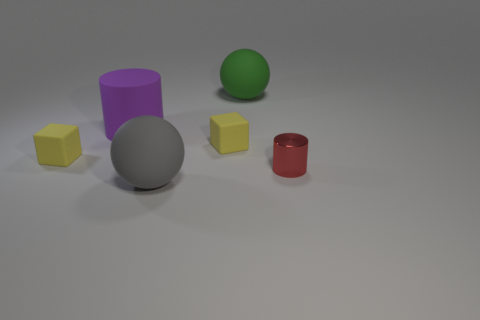Subtract all balls. How many objects are left? 4 Add 2 purple rubber cylinders. How many objects exist? 8 How many yellow cubes must be subtracted to get 1 yellow cubes? 1 Subtract 2 cubes. How many cubes are left? 0 Subtract all yellow spheres. Subtract all red cylinders. How many spheres are left? 2 Subtract all brown blocks. How many gray cylinders are left? 0 Subtract all tiny red shiny cylinders. Subtract all red cylinders. How many objects are left? 4 Add 1 red metal objects. How many red metal objects are left? 2 Add 4 large gray matte things. How many large gray matte things exist? 5 Subtract all gray spheres. How many spheres are left? 1 